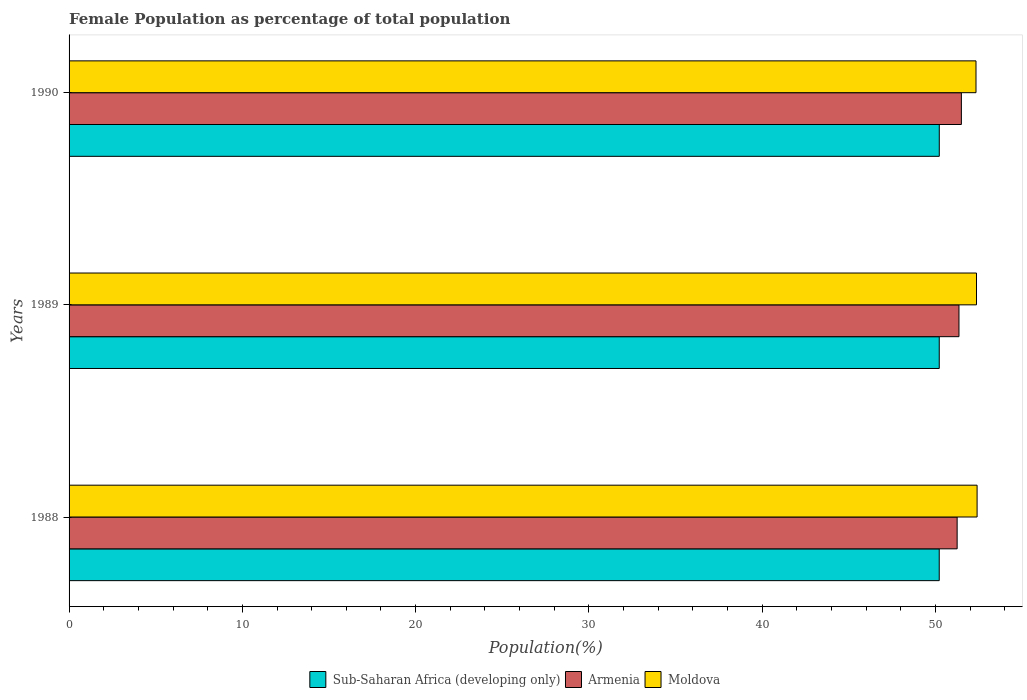Are the number of bars per tick equal to the number of legend labels?
Your response must be concise. Yes. How many bars are there on the 3rd tick from the top?
Keep it short and to the point. 3. What is the label of the 1st group of bars from the top?
Provide a short and direct response. 1990. In how many cases, is the number of bars for a given year not equal to the number of legend labels?
Your response must be concise. 0. What is the female population in in Moldova in 1990?
Offer a terse response. 52.34. Across all years, what is the maximum female population in in Sub-Saharan Africa (developing only)?
Provide a succinct answer. 50.22. Across all years, what is the minimum female population in in Armenia?
Ensure brevity in your answer.  51.25. In which year was the female population in in Armenia maximum?
Give a very brief answer. 1990. What is the total female population in in Moldova in the graph?
Provide a short and direct response. 157.1. What is the difference between the female population in in Moldova in 1988 and that in 1989?
Your response must be concise. 0.03. What is the difference between the female population in in Moldova in 1990 and the female population in in Sub-Saharan Africa (developing only) in 1989?
Your response must be concise. 2.12. What is the average female population in in Moldova per year?
Give a very brief answer. 52.37. In the year 1988, what is the difference between the female population in in Moldova and female population in in Sub-Saharan Africa (developing only)?
Offer a very short reply. 2.18. In how many years, is the female population in in Sub-Saharan Africa (developing only) greater than 50 %?
Your response must be concise. 3. What is the ratio of the female population in in Moldova in 1988 to that in 1990?
Provide a short and direct response. 1. Is the difference between the female population in in Moldova in 1988 and 1989 greater than the difference between the female population in in Sub-Saharan Africa (developing only) in 1988 and 1989?
Provide a short and direct response. Yes. What is the difference between the highest and the second highest female population in in Moldova?
Offer a very short reply. 0.03. What is the difference between the highest and the lowest female population in in Armenia?
Your response must be concise. 0.24. In how many years, is the female population in in Armenia greater than the average female population in in Armenia taken over all years?
Keep it short and to the point. 1. Is the sum of the female population in in Sub-Saharan Africa (developing only) in 1988 and 1989 greater than the maximum female population in in Moldova across all years?
Provide a succinct answer. Yes. What does the 2nd bar from the top in 1989 represents?
Offer a very short reply. Armenia. What does the 2nd bar from the bottom in 1989 represents?
Offer a terse response. Armenia. What is the difference between two consecutive major ticks on the X-axis?
Ensure brevity in your answer.  10. Are the values on the major ticks of X-axis written in scientific E-notation?
Provide a short and direct response. No. Does the graph contain grids?
Your answer should be very brief. No. Where does the legend appear in the graph?
Your response must be concise. Bottom center. How are the legend labels stacked?
Offer a terse response. Horizontal. What is the title of the graph?
Keep it short and to the point. Female Population as percentage of total population. Does "Tunisia" appear as one of the legend labels in the graph?
Keep it short and to the point. No. What is the label or title of the X-axis?
Your answer should be compact. Population(%). What is the Population(%) of Sub-Saharan Africa (developing only) in 1988?
Offer a very short reply. 50.22. What is the Population(%) in Armenia in 1988?
Provide a succinct answer. 51.25. What is the Population(%) of Moldova in 1988?
Provide a succinct answer. 52.4. What is the Population(%) of Sub-Saharan Africa (developing only) in 1989?
Offer a very short reply. 50.22. What is the Population(%) in Armenia in 1989?
Your answer should be very brief. 51.35. What is the Population(%) in Moldova in 1989?
Provide a short and direct response. 52.37. What is the Population(%) in Sub-Saharan Africa (developing only) in 1990?
Offer a terse response. 50.22. What is the Population(%) of Armenia in 1990?
Provide a succinct answer. 51.49. What is the Population(%) of Moldova in 1990?
Your answer should be compact. 52.34. Across all years, what is the maximum Population(%) of Sub-Saharan Africa (developing only)?
Your answer should be compact. 50.22. Across all years, what is the maximum Population(%) of Armenia?
Offer a terse response. 51.49. Across all years, what is the maximum Population(%) of Moldova?
Offer a very short reply. 52.4. Across all years, what is the minimum Population(%) in Sub-Saharan Africa (developing only)?
Provide a short and direct response. 50.22. Across all years, what is the minimum Population(%) in Armenia?
Provide a short and direct response. 51.25. Across all years, what is the minimum Population(%) in Moldova?
Your answer should be compact. 52.34. What is the total Population(%) of Sub-Saharan Africa (developing only) in the graph?
Offer a very short reply. 150.65. What is the total Population(%) in Armenia in the graph?
Provide a short and direct response. 154.1. What is the total Population(%) in Moldova in the graph?
Make the answer very short. 157.1. What is the difference between the Population(%) of Sub-Saharan Africa (developing only) in 1988 and that in 1989?
Your answer should be compact. -0. What is the difference between the Population(%) in Armenia in 1988 and that in 1989?
Provide a short and direct response. -0.11. What is the difference between the Population(%) in Moldova in 1988 and that in 1989?
Your answer should be compact. 0.03. What is the difference between the Population(%) of Sub-Saharan Africa (developing only) in 1988 and that in 1990?
Your response must be concise. -0. What is the difference between the Population(%) of Armenia in 1988 and that in 1990?
Your answer should be compact. -0.24. What is the difference between the Population(%) of Moldova in 1988 and that in 1990?
Keep it short and to the point. 0.06. What is the difference between the Population(%) of Sub-Saharan Africa (developing only) in 1989 and that in 1990?
Offer a terse response. -0. What is the difference between the Population(%) of Armenia in 1989 and that in 1990?
Provide a succinct answer. -0.14. What is the difference between the Population(%) in Moldova in 1989 and that in 1990?
Keep it short and to the point. 0.03. What is the difference between the Population(%) of Sub-Saharan Africa (developing only) in 1988 and the Population(%) of Armenia in 1989?
Make the answer very short. -1.14. What is the difference between the Population(%) of Sub-Saharan Africa (developing only) in 1988 and the Population(%) of Moldova in 1989?
Provide a short and direct response. -2.15. What is the difference between the Population(%) in Armenia in 1988 and the Population(%) in Moldova in 1989?
Your answer should be compact. -1.12. What is the difference between the Population(%) of Sub-Saharan Africa (developing only) in 1988 and the Population(%) of Armenia in 1990?
Ensure brevity in your answer.  -1.28. What is the difference between the Population(%) of Sub-Saharan Africa (developing only) in 1988 and the Population(%) of Moldova in 1990?
Make the answer very short. -2.12. What is the difference between the Population(%) in Armenia in 1988 and the Population(%) in Moldova in 1990?
Make the answer very short. -1.09. What is the difference between the Population(%) in Sub-Saharan Africa (developing only) in 1989 and the Population(%) in Armenia in 1990?
Offer a terse response. -1.28. What is the difference between the Population(%) of Sub-Saharan Africa (developing only) in 1989 and the Population(%) of Moldova in 1990?
Keep it short and to the point. -2.12. What is the difference between the Population(%) of Armenia in 1989 and the Population(%) of Moldova in 1990?
Make the answer very short. -0.98. What is the average Population(%) in Sub-Saharan Africa (developing only) per year?
Keep it short and to the point. 50.22. What is the average Population(%) of Armenia per year?
Ensure brevity in your answer.  51.37. What is the average Population(%) in Moldova per year?
Your answer should be very brief. 52.37. In the year 1988, what is the difference between the Population(%) of Sub-Saharan Africa (developing only) and Population(%) of Armenia?
Ensure brevity in your answer.  -1.03. In the year 1988, what is the difference between the Population(%) of Sub-Saharan Africa (developing only) and Population(%) of Moldova?
Provide a succinct answer. -2.18. In the year 1988, what is the difference between the Population(%) of Armenia and Population(%) of Moldova?
Keep it short and to the point. -1.15. In the year 1989, what is the difference between the Population(%) of Sub-Saharan Africa (developing only) and Population(%) of Armenia?
Ensure brevity in your answer.  -1.14. In the year 1989, what is the difference between the Population(%) of Sub-Saharan Africa (developing only) and Population(%) of Moldova?
Offer a terse response. -2.15. In the year 1989, what is the difference between the Population(%) of Armenia and Population(%) of Moldova?
Provide a short and direct response. -1.01. In the year 1990, what is the difference between the Population(%) in Sub-Saharan Africa (developing only) and Population(%) in Armenia?
Keep it short and to the point. -1.28. In the year 1990, what is the difference between the Population(%) of Sub-Saharan Africa (developing only) and Population(%) of Moldova?
Your answer should be very brief. -2.12. In the year 1990, what is the difference between the Population(%) of Armenia and Population(%) of Moldova?
Your response must be concise. -0.84. What is the ratio of the Population(%) in Sub-Saharan Africa (developing only) in 1988 to that in 1989?
Give a very brief answer. 1. What is the ratio of the Population(%) of Armenia in 1988 to that in 1989?
Make the answer very short. 1. What is the ratio of the Population(%) in Sub-Saharan Africa (developing only) in 1988 to that in 1990?
Your answer should be compact. 1. What is the ratio of the Population(%) of Armenia in 1988 to that in 1990?
Your response must be concise. 1. What is the ratio of the Population(%) of Sub-Saharan Africa (developing only) in 1989 to that in 1990?
Give a very brief answer. 1. What is the ratio of the Population(%) in Armenia in 1989 to that in 1990?
Provide a succinct answer. 1. What is the ratio of the Population(%) in Moldova in 1989 to that in 1990?
Your response must be concise. 1. What is the difference between the highest and the second highest Population(%) in Sub-Saharan Africa (developing only)?
Keep it short and to the point. 0. What is the difference between the highest and the second highest Population(%) of Armenia?
Keep it short and to the point. 0.14. What is the difference between the highest and the second highest Population(%) of Moldova?
Your answer should be compact. 0.03. What is the difference between the highest and the lowest Population(%) of Sub-Saharan Africa (developing only)?
Your answer should be compact. 0. What is the difference between the highest and the lowest Population(%) of Armenia?
Your answer should be very brief. 0.24. What is the difference between the highest and the lowest Population(%) in Moldova?
Make the answer very short. 0.06. 